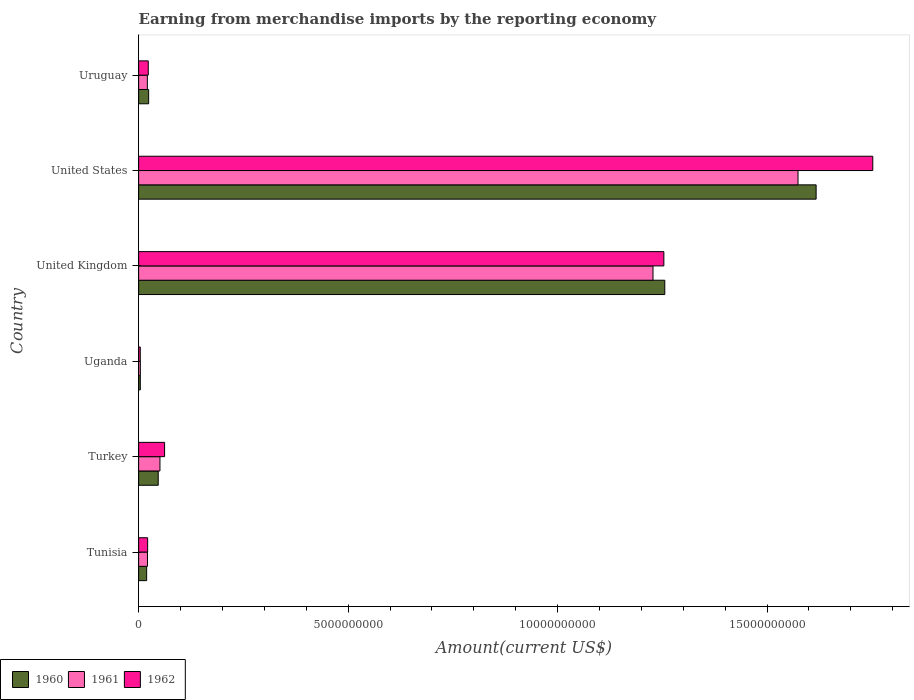Are the number of bars on each tick of the Y-axis equal?
Provide a succinct answer. Yes. How many bars are there on the 6th tick from the top?
Offer a terse response. 3. How many bars are there on the 6th tick from the bottom?
Offer a terse response. 3. What is the label of the 4th group of bars from the top?
Give a very brief answer. Uganda. What is the amount earned from merchandise imports in 1962 in Tunisia?
Provide a short and direct response. 2.15e+08. Across all countries, what is the maximum amount earned from merchandise imports in 1960?
Give a very brief answer. 1.62e+1. Across all countries, what is the minimum amount earned from merchandise imports in 1960?
Provide a short and direct response. 4.01e+07. In which country was the amount earned from merchandise imports in 1962 minimum?
Provide a short and direct response. Uganda. What is the total amount earned from merchandise imports in 1962 in the graph?
Make the answer very short. 3.12e+1. What is the difference between the amount earned from merchandise imports in 1962 in Tunisia and that in Uganda?
Make the answer very short. 1.76e+08. What is the difference between the amount earned from merchandise imports in 1960 in Uganda and the amount earned from merchandise imports in 1962 in Turkey?
Your answer should be very brief. -5.79e+08. What is the average amount earned from merchandise imports in 1960 per country?
Your answer should be very brief. 4.94e+09. What is the difference between the amount earned from merchandise imports in 1961 and amount earned from merchandise imports in 1960 in Tunisia?
Keep it short and to the point. 2.03e+07. In how many countries, is the amount earned from merchandise imports in 1960 greater than 15000000000 US$?
Your answer should be very brief. 1. What is the ratio of the amount earned from merchandise imports in 1960 in Turkey to that in United States?
Your answer should be very brief. 0.03. Is the amount earned from merchandise imports in 1960 in United States less than that in Uruguay?
Give a very brief answer. No. What is the difference between the highest and the second highest amount earned from merchandise imports in 1960?
Keep it short and to the point. 3.61e+09. What is the difference between the highest and the lowest amount earned from merchandise imports in 1960?
Provide a succinct answer. 1.61e+1. What does the 2nd bar from the bottom in Turkey represents?
Make the answer very short. 1961. Is it the case that in every country, the sum of the amount earned from merchandise imports in 1962 and amount earned from merchandise imports in 1961 is greater than the amount earned from merchandise imports in 1960?
Your response must be concise. Yes. How many bars are there?
Ensure brevity in your answer.  18. Are all the bars in the graph horizontal?
Provide a succinct answer. Yes. Are the values on the major ticks of X-axis written in scientific E-notation?
Provide a short and direct response. No. Does the graph contain any zero values?
Your answer should be compact. No. Where does the legend appear in the graph?
Your answer should be compact. Bottom left. What is the title of the graph?
Keep it short and to the point. Earning from merchandise imports by the reporting economy. What is the label or title of the X-axis?
Give a very brief answer. Amount(current US$). What is the label or title of the Y-axis?
Provide a succinct answer. Country. What is the Amount(current US$) in 1960 in Tunisia?
Offer a very short reply. 1.91e+08. What is the Amount(current US$) in 1961 in Tunisia?
Provide a short and direct response. 2.11e+08. What is the Amount(current US$) of 1962 in Tunisia?
Give a very brief answer. 2.15e+08. What is the Amount(current US$) in 1960 in Turkey?
Your answer should be compact. 4.68e+08. What is the Amount(current US$) in 1961 in Turkey?
Your response must be concise. 5.09e+08. What is the Amount(current US$) of 1962 in Turkey?
Provide a short and direct response. 6.19e+08. What is the Amount(current US$) in 1960 in Uganda?
Keep it short and to the point. 4.01e+07. What is the Amount(current US$) in 1961 in Uganda?
Ensure brevity in your answer.  4.11e+07. What is the Amount(current US$) in 1962 in Uganda?
Offer a terse response. 3.90e+07. What is the Amount(current US$) in 1960 in United Kingdom?
Keep it short and to the point. 1.26e+1. What is the Amount(current US$) in 1961 in United Kingdom?
Ensure brevity in your answer.  1.23e+1. What is the Amount(current US$) of 1962 in United Kingdom?
Give a very brief answer. 1.25e+1. What is the Amount(current US$) in 1960 in United States?
Ensure brevity in your answer.  1.62e+1. What is the Amount(current US$) of 1961 in United States?
Offer a terse response. 1.57e+1. What is the Amount(current US$) in 1962 in United States?
Offer a terse response. 1.75e+1. What is the Amount(current US$) in 1960 in Uruguay?
Provide a succinct answer. 2.39e+08. What is the Amount(current US$) of 1961 in Uruguay?
Your response must be concise. 2.08e+08. What is the Amount(current US$) in 1962 in Uruguay?
Your answer should be compact. 2.30e+08. Across all countries, what is the maximum Amount(current US$) in 1960?
Ensure brevity in your answer.  1.62e+1. Across all countries, what is the maximum Amount(current US$) of 1961?
Offer a terse response. 1.57e+1. Across all countries, what is the maximum Amount(current US$) in 1962?
Your answer should be compact. 1.75e+1. Across all countries, what is the minimum Amount(current US$) in 1960?
Ensure brevity in your answer.  4.01e+07. Across all countries, what is the minimum Amount(current US$) in 1961?
Provide a short and direct response. 4.11e+07. Across all countries, what is the minimum Amount(current US$) in 1962?
Provide a short and direct response. 3.90e+07. What is the total Amount(current US$) of 1960 in the graph?
Your response must be concise. 2.97e+1. What is the total Amount(current US$) of 1961 in the graph?
Your answer should be very brief. 2.90e+1. What is the total Amount(current US$) of 1962 in the graph?
Your response must be concise. 3.12e+1. What is the difference between the Amount(current US$) in 1960 in Tunisia and that in Turkey?
Keep it short and to the point. -2.77e+08. What is the difference between the Amount(current US$) in 1961 in Tunisia and that in Turkey?
Make the answer very short. -2.97e+08. What is the difference between the Amount(current US$) in 1962 in Tunisia and that in Turkey?
Offer a terse response. -4.04e+08. What is the difference between the Amount(current US$) in 1960 in Tunisia and that in Uganda?
Your response must be concise. 1.51e+08. What is the difference between the Amount(current US$) of 1961 in Tunisia and that in Uganda?
Provide a short and direct response. 1.70e+08. What is the difference between the Amount(current US$) of 1962 in Tunisia and that in Uganda?
Your response must be concise. 1.76e+08. What is the difference between the Amount(current US$) of 1960 in Tunisia and that in United Kingdom?
Ensure brevity in your answer.  -1.24e+1. What is the difference between the Amount(current US$) in 1961 in Tunisia and that in United Kingdom?
Your response must be concise. -1.21e+1. What is the difference between the Amount(current US$) of 1962 in Tunisia and that in United Kingdom?
Your answer should be very brief. -1.23e+1. What is the difference between the Amount(current US$) in 1960 in Tunisia and that in United States?
Ensure brevity in your answer.  -1.60e+1. What is the difference between the Amount(current US$) in 1961 in Tunisia and that in United States?
Offer a very short reply. -1.55e+1. What is the difference between the Amount(current US$) of 1962 in Tunisia and that in United States?
Your response must be concise. -1.73e+1. What is the difference between the Amount(current US$) in 1960 in Tunisia and that in Uruguay?
Your answer should be very brief. -4.80e+07. What is the difference between the Amount(current US$) in 1961 in Tunisia and that in Uruguay?
Your answer should be compact. 3.10e+06. What is the difference between the Amount(current US$) in 1962 in Tunisia and that in Uruguay?
Offer a very short reply. -1.48e+07. What is the difference between the Amount(current US$) in 1960 in Turkey and that in Uganda?
Offer a very short reply. 4.28e+08. What is the difference between the Amount(current US$) in 1961 in Turkey and that in Uganda?
Provide a short and direct response. 4.68e+08. What is the difference between the Amount(current US$) in 1962 in Turkey and that in Uganda?
Your response must be concise. 5.80e+08. What is the difference between the Amount(current US$) of 1960 in Turkey and that in United Kingdom?
Give a very brief answer. -1.21e+1. What is the difference between the Amount(current US$) in 1961 in Turkey and that in United Kingdom?
Keep it short and to the point. -1.18e+1. What is the difference between the Amount(current US$) of 1962 in Turkey and that in United Kingdom?
Your answer should be compact. -1.19e+1. What is the difference between the Amount(current US$) of 1960 in Turkey and that in United States?
Provide a succinct answer. -1.57e+1. What is the difference between the Amount(current US$) in 1961 in Turkey and that in United States?
Make the answer very short. -1.52e+1. What is the difference between the Amount(current US$) in 1962 in Turkey and that in United States?
Provide a succinct answer. -1.69e+1. What is the difference between the Amount(current US$) in 1960 in Turkey and that in Uruguay?
Provide a succinct answer. 2.29e+08. What is the difference between the Amount(current US$) of 1961 in Turkey and that in Uruguay?
Keep it short and to the point. 3.00e+08. What is the difference between the Amount(current US$) in 1962 in Turkey and that in Uruguay?
Your answer should be very brief. 3.89e+08. What is the difference between the Amount(current US$) in 1960 in Uganda and that in United Kingdom?
Give a very brief answer. -1.25e+1. What is the difference between the Amount(current US$) in 1961 in Uganda and that in United Kingdom?
Ensure brevity in your answer.  -1.22e+1. What is the difference between the Amount(current US$) of 1962 in Uganda and that in United Kingdom?
Provide a succinct answer. -1.25e+1. What is the difference between the Amount(current US$) of 1960 in Uganda and that in United States?
Keep it short and to the point. -1.61e+1. What is the difference between the Amount(current US$) in 1961 in Uganda and that in United States?
Ensure brevity in your answer.  -1.57e+1. What is the difference between the Amount(current US$) of 1962 in Uganda and that in United States?
Make the answer very short. -1.75e+1. What is the difference between the Amount(current US$) in 1960 in Uganda and that in Uruguay?
Your answer should be compact. -1.99e+08. What is the difference between the Amount(current US$) of 1961 in Uganda and that in Uruguay?
Your answer should be very brief. -1.67e+08. What is the difference between the Amount(current US$) in 1962 in Uganda and that in Uruguay?
Your answer should be compact. -1.91e+08. What is the difference between the Amount(current US$) in 1960 in United Kingdom and that in United States?
Provide a short and direct response. -3.61e+09. What is the difference between the Amount(current US$) in 1961 in United Kingdom and that in United States?
Make the answer very short. -3.46e+09. What is the difference between the Amount(current US$) in 1962 in United Kingdom and that in United States?
Make the answer very short. -4.99e+09. What is the difference between the Amount(current US$) of 1960 in United Kingdom and that in Uruguay?
Offer a very short reply. 1.23e+1. What is the difference between the Amount(current US$) of 1961 in United Kingdom and that in Uruguay?
Ensure brevity in your answer.  1.21e+1. What is the difference between the Amount(current US$) in 1962 in United Kingdom and that in Uruguay?
Provide a succinct answer. 1.23e+1. What is the difference between the Amount(current US$) in 1960 in United States and that in Uruguay?
Give a very brief answer. 1.59e+1. What is the difference between the Amount(current US$) in 1961 in United States and that in Uruguay?
Offer a terse response. 1.55e+1. What is the difference between the Amount(current US$) in 1962 in United States and that in Uruguay?
Provide a short and direct response. 1.73e+1. What is the difference between the Amount(current US$) in 1960 in Tunisia and the Amount(current US$) in 1961 in Turkey?
Your response must be concise. -3.18e+08. What is the difference between the Amount(current US$) of 1960 in Tunisia and the Amount(current US$) of 1962 in Turkey?
Your answer should be very brief. -4.28e+08. What is the difference between the Amount(current US$) of 1961 in Tunisia and the Amount(current US$) of 1962 in Turkey?
Make the answer very short. -4.08e+08. What is the difference between the Amount(current US$) in 1960 in Tunisia and the Amount(current US$) in 1961 in Uganda?
Provide a short and direct response. 1.50e+08. What is the difference between the Amount(current US$) in 1960 in Tunisia and the Amount(current US$) in 1962 in Uganda?
Ensure brevity in your answer.  1.52e+08. What is the difference between the Amount(current US$) in 1961 in Tunisia and the Amount(current US$) in 1962 in Uganda?
Your response must be concise. 1.72e+08. What is the difference between the Amount(current US$) in 1960 in Tunisia and the Amount(current US$) in 1961 in United Kingdom?
Provide a succinct answer. -1.21e+1. What is the difference between the Amount(current US$) of 1960 in Tunisia and the Amount(current US$) of 1962 in United Kingdom?
Give a very brief answer. -1.23e+1. What is the difference between the Amount(current US$) of 1961 in Tunisia and the Amount(current US$) of 1962 in United Kingdom?
Ensure brevity in your answer.  -1.23e+1. What is the difference between the Amount(current US$) of 1960 in Tunisia and the Amount(current US$) of 1961 in United States?
Give a very brief answer. -1.55e+1. What is the difference between the Amount(current US$) of 1960 in Tunisia and the Amount(current US$) of 1962 in United States?
Provide a short and direct response. -1.73e+1. What is the difference between the Amount(current US$) of 1961 in Tunisia and the Amount(current US$) of 1962 in United States?
Provide a succinct answer. -1.73e+1. What is the difference between the Amount(current US$) of 1960 in Tunisia and the Amount(current US$) of 1961 in Uruguay?
Your answer should be compact. -1.72e+07. What is the difference between the Amount(current US$) of 1960 in Tunisia and the Amount(current US$) of 1962 in Uruguay?
Your answer should be very brief. -3.89e+07. What is the difference between the Amount(current US$) in 1961 in Tunisia and the Amount(current US$) in 1962 in Uruguay?
Offer a terse response. -1.86e+07. What is the difference between the Amount(current US$) of 1960 in Turkey and the Amount(current US$) of 1961 in Uganda?
Keep it short and to the point. 4.27e+08. What is the difference between the Amount(current US$) of 1960 in Turkey and the Amount(current US$) of 1962 in Uganda?
Provide a short and direct response. 4.29e+08. What is the difference between the Amount(current US$) of 1961 in Turkey and the Amount(current US$) of 1962 in Uganda?
Your answer should be very brief. 4.70e+08. What is the difference between the Amount(current US$) of 1960 in Turkey and the Amount(current US$) of 1961 in United Kingdom?
Provide a succinct answer. -1.18e+1. What is the difference between the Amount(current US$) in 1960 in Turkey and the Amount(current US$) in 1962 in United Kingdom?
Provide a succinct answer. -1.21e+1. What is the difference between the Amount(current US$) in 1961 in Turkey and the Amount(current US$) in 1962 in United Kingdom?
Make the answer very short. -1.20e+1. What is the difference between the Amount(current US$) in 1960 in Turkey and the Amount(current US$) in 1961 in United States?
Ensure brevity in your answer.  -1.53e+1. What is the difference between the Amount(current US$) of 1960 in Turkey and the Amount(current US$) of 1962 in United States?
Offer a terse response. -1.71e+1. What is the difference between the Amount(current US$) in 1961 in Turkey and the Amount(current US$) in 1962 in United States?
Provide a short and direct response. -1.70e+1. What is the difference between the Amount(current US$) of 1960 in Turkey and the Amount(current US$) of 1961 in Uruguay?
Offer a very short reply. 2.59e+08. What is the difference between the Amount(current US$) of 1960 in Turkey and the Amount(current US$) of 1962 in Uruguay?
Provide a short and direct response. 2.38e+08. What is the difference between the Amount(current US$) of 1961 in Turkey and the Amount(current US$) of 1962 in Uruguay?
Offer a terse response. 2.79e+08. What is the difference between the Amount(current US$) of 1960 in Uganda and the Amount(current US$) of 1961 in United Kingdom?
Provide a succinct answer. -1.22e+1. What is the difference between the Amount(current US$) of 1960 in Uganda and the Amount(current US$) of 1962 in United Kingdom?
Your answer should be compact. -1.25e+1. What is the difference between the Amount(current US$) in 1961 in Uganda and the Amount(current US$) in 1962 in United Kingdom?
Provide a succinct answer. -1.25e+1. What is the difference between the Amount(current US$) of 1960 in Uganda and the Amount(current US$) of 1961 in United States?
Offer a terse response. -1.57e+1. What is the difference between the Amount(current US$) in 1960 in Uganda and the Amount(current US$) in 1962 in United States?
Your response must be concise. -1.75e+1. What is the difference between the Amount(current US$) in 1961 in Uganda and the Amount(current US$) in 1962 in United States?
Give a very brief answer. -1.75e+1. What is the difference between the Amount(current US$) of 1960 in Uganda and the Amount(current US$) of 1961 in Uruguay?
Keep it short and to the point. -1.68e+08. What is the difference between the Amount(current US$) of 1960 in Uganda and the Amount(current US$) of 1962 in Uruguay?
Make the answer very short. -1.90e+08. What is the difference between the Amount(current US$) of 1961 in Uganda and the Amount(current US$) of 1962 in Uruguay?
Offer a terse response. -1.89e+08. What is the difference between the Amount(current US$) of 1960 in United Kingdom and the Amount(current US$) of 1961 in United States?
Offer a very short reply. -3.18e+09. What is the difference between the Amount(current US$) in 1960 in United Kingdom and the Amount(current US$) in 1962 in United States?
Offer a terse response. -4.96e+09. What is the difference between the Amount(current US$) of 1961 in United Kingdom and the Amount(current US$) of 1962 in United States?
Offer a terse response. -5.25e+09. What is the difference between the Amount(current US$) of 1960 in United Kingdom and the Amount(current US$) of 1961 in Uruguay?
Give a very brief answer. 1.24e+1. What is the difference between the Amount(current US$) of 1960 in United Kingdom and the Amount(current US$) of 1962 in Uruguay?
Provide a succinct answer. 1.23e+1. What is the difference between the Amount(current US$) of 1961 in United Kingdom and the Amount(current US$) of 1962 in Uruguay?
Your answer should be compact. 1.20e+1. What is the difference between the Amount(current US$) in 1960 in United States and the Amount(current US$) in 1961 in Uruguay?
Provide a short and direct response. 1.60e+1. What is the difference between the Amount(current US$) in 1960 in United States and the Amount(current US$) in 1962 in Uruguay?
Provide a short and direct response. 1.59e+1. What is the difference between the Amount(current US$) in 1961 in United States and the Amount(current US$) in 1962 in Uruguay?
Your answer should be compact. 1.55e+1. What is the average Amount(current US$) in 1960 per country?
Provide a short and direct response. 4.94e+09. What is the average Amount(current US$) in 1961 per country?
Give a very brief answer. 4.83e+09. What is the average Amount(current US$) in 1962 per country?
Your answer should be very brief. 5.19e+09. What is the difference between the Amount(current US$) in 1960 and Amount(current US$) in 1961 in Tunisia?
Offer a very short reply. -2.03e+07. What is the difference between the Amount(current US$) of 1960 and Amount(current US$) of 1962 in Tunisia?
Offer a terse response. -2.41e+07. What is the difference between the Amount(current US$) in 1961 and Amount(current US$) in 1962 in Tunisia?
Your response must be concise. -3.80e+06. What is the difference between the Amount(current US$) in 1960 and Amount(current US$) in 1961 in Turkey?
Provide a succinct answer. -4.11e+07. What is the difference between the Amount(current US$) in 1960 and Amount(current US$) in 1962 in Turkey?
Offer a terse response. -1.52e+08. What is the difference between the Amount(current US$) of 1961 and Amount(current US$) of 1962 in Turkey?
Give a very brief answer. -1.10e+08. What is the difference between the Amount(current US$) in 1960 and Amount(current US$) in 1962 in Uganda?
Make the answer very short. 1.10e+06. What is the difference between the Amount(current US$) in 1961 and Amount(current US$) in 1962 in Uganda?
Provide a short and direct response. 2.10e+06. What is the difference between the Amount(current US$) in 1960 and Amount(current US$) in 1961 in United Kingdom?
Offer a very short reply. 2.82e+08. What is the difference between the Amount(current US$) in 1960 and Amount(current US$) in 1962 in United Kingdom?
Give a very brief answer. 2.22e+07. What is the difference between the Amount(current US$) in 1961 and Amount(current US$) in 1962 in United Kingdom?
Provide a short and direct response. -2.59e+08. What is the difference between the Amount(current US$) of 1960 and Amount(current US$) of 1961 in United States?
Give a very brief answer. 4.32e+08. What is the difference between the Amount(current US$) in 1960 and Amount(current US$) in 1962 in United States?
Keep it short and to the point. -1.35e+09. What is the difference between the Amount(current US$) of 1961 and Amount(current US$) of 1962 in United States?
Give a very brief answer. -1.78e+09. What is the difference between the Amount(current US$) of 1960 and Amount(current US$) of 1961 in Uruguay?
Make the answer very short. 3.08e+07. What is the difference between the Amount(current US$) of 1960 and Amount(current US$) of 1962 in Uruguay?
Give a very brief answer. 9.10e+06. What is the difference between the Amount(current US$) of 1961 and Amount(current US$) of 1962 in Uruguay?
Offer a very short reply. -2.17e+07. What is the ratio of the Amount(current US$) in 1960 in Tunisia to that in Turkey?
Offer a terse response. 0.41. What is the ratio of the Amount(current US$) of 1961 in Tunisia to that in Turkey?
Your answer should be compact. 0.42. What is the ratio of the Amount(current US$) in 1962 in Tunisia to that in Turkey?
Provide a succinct answer. 0.35. What is the ratio of the Amount(current US$) in 1960 in Tunisia to that in Uganda?
Ensure brevity in your answer.  4.77. What is the ratio of the Amount(current US$) of 1961 in Tunisia to that in Uganda?
Make the answer very short. 5.14. What is the ratio of the Amount(current US$) of 1962 in Tunisia to that in Uganda?
Provide a short and direct response. 5.52. What is the ratio of the Amount(current US$) of 1960 in Tunisia to that in United Kingdom?
Your answer should be compact. 0.02. What is the ratio of the Amount(current US$) of 1961 in Tunisia to that in United Kingdom?
Ensure brevity in your answer.  0.02. What is the ratio of the Amount(current US$) in 1962 in Tunisia to that in United Kingdom?
Provide a succinct answer. 0.02. What is the ratio of the Amount(current US$) in 1960 in Tunisia to that in United States?
Offer a terse response. 0.01. What is the ratio of the Amount(current US$) in 1961 in Tunisia to that in United States?
Your response must be concise. 0.01. What is the ratio of the Amount(current US$) in 1962 in Tunisia to that in United States?
Your answer should be very brief. 0.01. What is the ratio of the Amount(current US$) in 1960 in Tunisia to that in Uruguay?
Your answer should be compact. 0.8. What is the ratio of the Amount(current US$) in 1961 in Tunisia to that in Uruguay?
Ensure brevity in your answer.  1.01. What is the ratio of the Amount(current US$) of 1962 in Tunisia to that in Uruguay?
Provide a succinct answer. 0.94. What is the ratio of the Amount(current US$) in 1960 in Turkey to that in Uganda?
Provide a short and direct response. 11.66. What is the ratio of the Amount(current US$) in 1961 in Turkey to that in Uganda?
Provide a short and direct response. 12.38. What is the ratio of the Amount(current US$) in 1962 in Turkey to that in Uganda?
Provide a succinct answer. 15.88. What is the ratio of the Amount(current US$) in 1960 in Turkey to that in United Kingdom?
Provide a short and direct response. 0.04. What is the ratio of the Amount(current US$) of 1961 in Turkey to that in United Kingdom?
Keep it short and to the point. 0.04. What is the ratio of the Amount(current US$) in 1962 in Turkey to that in United Kingdom?
Give a very brief answer. 0.05. What is the ratio of the Amount(current US$) of 1960 in Turkey to that in United States?
Your answer should be very brief. 0.03. What is the ratio of the Amount(current US$) in 1961 in Turkey to that in United States?
Your response must be concise. 0.03. What is the ratio of the Amount(current US$) of 1962 in Turkey to that in United States?
Your response must be concise. 0.04. What is the ratio of the Amount(current US$) of 1960 in Turkey to that in Uruguay?
Offer a terse response. 1.96. What is the ratio of the Amount(current US$) of 1961 in Turkey to that in Uruguay?
Ensure brevity in your answer.  2.44. What is the ratio of the Amount(current US$) in 1962 in Turkey to that in Uruguay?
Provide a succinct answer. 2.69. What is the ratio of the Amount(current US$) of 1960 in Uganda to that in United Kingdom?
Give a very brief answer. 0. What is the ratio of the Amount(current US$) in 1961 in Uganda to that in United Kingdom?
Give a very brief answer. 0. What is the ratio of the Amount(current US$) of 1962 in Uganda to that in United Kingdom?
Your answer should be very brief. 0. What is the ratio of the Amount(current US$) of 1960 in Uganda to that in United States?
Offer a terse response. 0. What is the ratio of the Amount(current US$) of 1961 in Uganda to that in United States?
Keep it short and to the point. 0. What is the ratio of the Amount(current US$) in 1962 in Uganda to that in United States?
Make the answer very short. 0. What is the ratio of the Amount(current US$) in 1960 in Uganda to that in Uruguay?
Provide a short and direct response. 0.17. What is the ratio of the Amount(current US$) in 1961 in Uganda to that in Uruguay?
Your answer should be compact. 0.2. What is the ratio of the Amount(current US$) in 1962 in Uganda to that in Uruguay?
Give a very brief answer. 0.17. What is the ratio of the Amount(current US$) in 1960 in United Kingdom to that in United States?
Your response must be concise. 0.78. What is the ratio of the Amount(current US$) of 1961 in United Kingdom to that in United States?
Your response must be concise. 0.78. What is the ratio of the Amount(current US$) in 1962 in United Kingdom to that in United States?
Provide a short and direct response. 0.72. What is the ratio of the Amount(current US$) of 1960 in United Kingdom to that in Uruguay?
Your response must be concise. 52.52. What is the ratio of the Amount(current US$) of 1961 in United Kingdom to that in Uruguay?
Keep it short and to the point. 58.94. What is the ratio of the Amount(current US$) of 1962 in United Kingdom to that in Uruguay?
Offer a terse response. 54.51. What is the ratio of the Amount(current US$) in 1960 in United States to that in Uruguay?
Give a very brief answer. 67.63. What is the ratio of the Amount(current US$) of 1961 in United States to that in Uruguay?
Your response must be concise. 75.56. What is the ratio of the Amount(current US$) of 1962 in United States to that in Uruguay?
Your answer should be compact. 76.19. What is the difference between the highest and the second highest Amount(current US$) of 1960?
Provide a short and direct response. 3.61e+09. What is the difference between the highest and the second highest Amount(current US$) in 1961?
Your answer should be compact. 3.46e+09. What is the difference between the highest and the second highest Amount(current US$) in 1962?
Make the answer very short. 4.99e+09. What is the difference between the highest and the lowest Amount(current US$) in 1960?
Your response must be concise. 1.61e+1. What is the difference between the highest and the lowest Amount(current US$) in 1961?
Your response must be concise. 1.57e+1. What is the difference between the highest and the lowest Amount(current US$) in 1962?
Provide a short and direct response. 1.75e+1. 